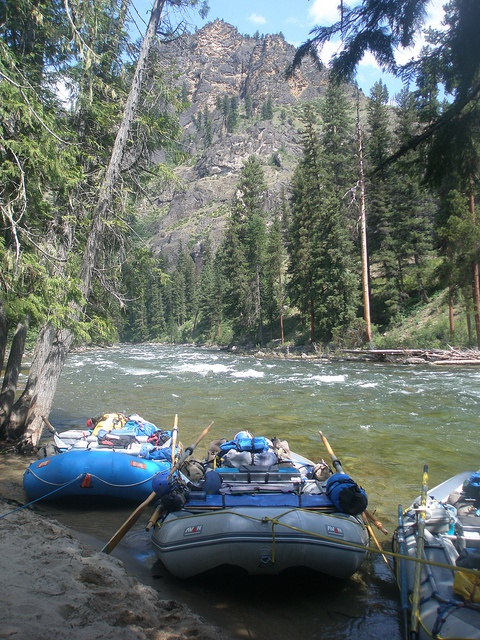Describe the objects in this image and their specific colors. I can see boat in blue, black, gray, and navy tones, boat in blue, gray, black, and navy tones, and boat in blue, white, navy, and black tones in this image. 